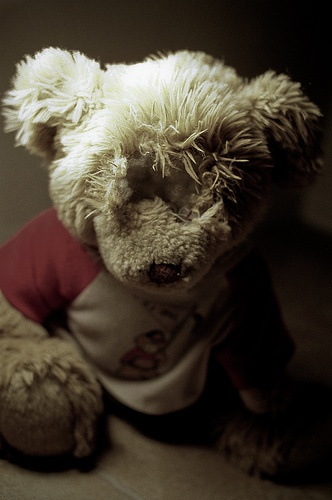Describe the objects in this image and their specific colors. I can see a teddy bear in black, maroon, gray, and lightgray tones in this image. 